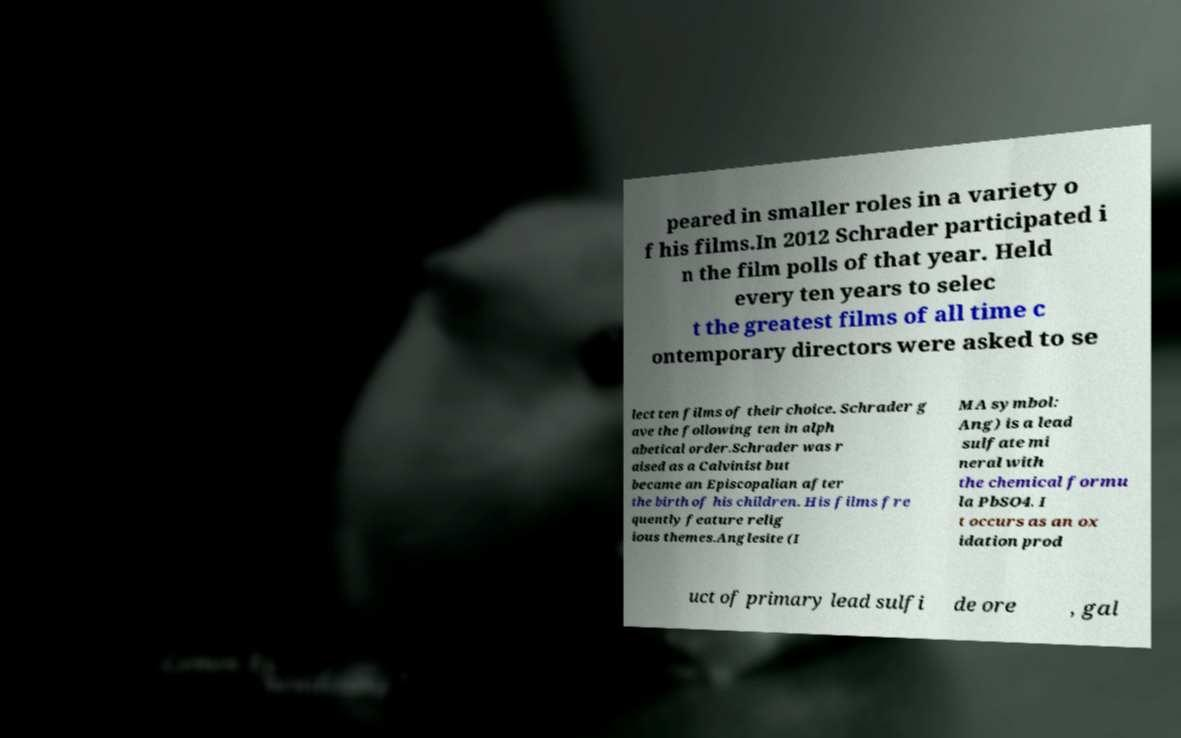Please identify and transcribe the text found in this image. peared in smaller roles in a variety o f his films.In 2012 Schrader participated i n the film polls of that year. Held every ten years to selec t the greatest films of all time c ontemporary directors were asked to se lect ten films of their choice. Schrader g ave the following ten in alph abetical order.Schrader was r aised as a Calvinist but became an Episcopalian after the birth of his children. His films fre quently feature relig ious themes.Anglesite (I MA symbol: Ang) is a lead sulfate mi neral with the chemical formu la PbSO4. I t occurs as an ox idation prod uct of primary lead sulfi de ore , gal 